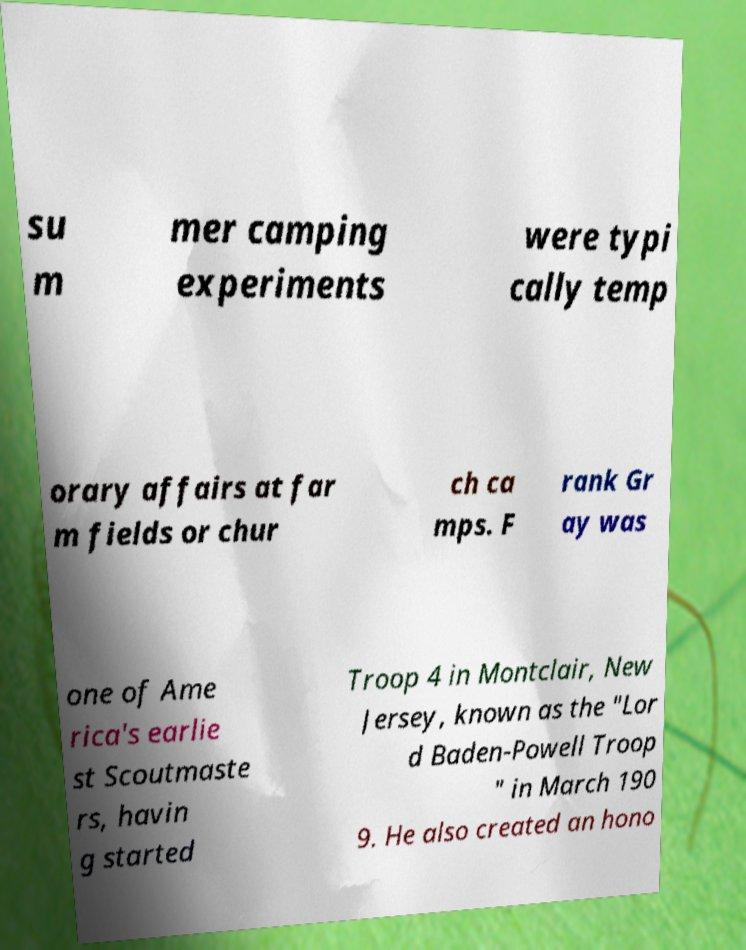Could you extract and type out the text from this image? su m mer camping experiments were typi cally temp orary affairs at far m fields or chur ch ca mps. F rank Gr ay was one of Ame rica's earlie st Scoutmaste rs, havin g started Troop 4 in Montclair, New Jersey, known as the "Lor d Baden-Powell Troop " in March 190 9. He also created an hono 